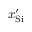Convert formula to latex. <formula><loc_0><loc_0><loc_500><loc_500>x _ { S i } ^ { \prime }</formula> 